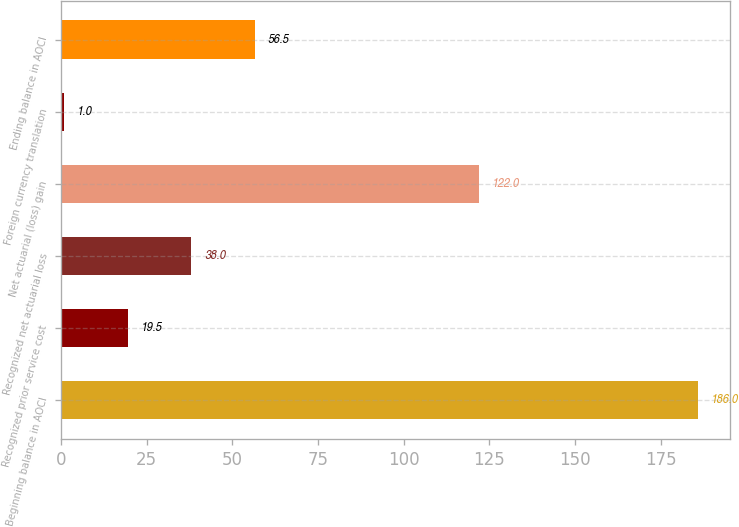Convert chart to OTSL. <chart><loc_0><loc_0><loc_500><loc_500><bar_chart><fcel>Beginning balance in AOCI<fcel>Recognized prior service cost<fcel>Recognized net actuarial loss<fcel>Net actuarial (loss) gain<fcel>Foreign currency translation<fcel>Ending balance in AOCI<nl><fcel>186<fcel>19.5<fcel>38<fcel>122<fcel>1<fcel>56.5<nl></chart> 